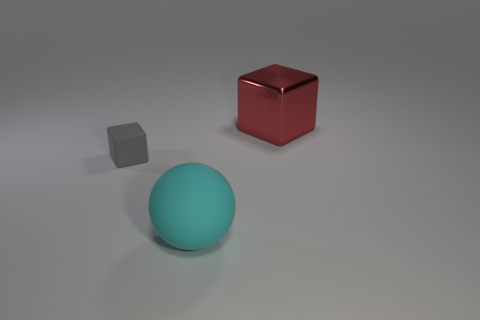Do the big block and the object that is in front of the small gray rubber block have the same color?
Your answer should be very brief. No. Is the number of small purple cylinders greater than the number of big red metallic objects?
Keep it short and to the point. No. What size is the red object that is the same shape as the gray object?
Offer a very short reply. Large. Are the large ball and the big thing that is behind the large cyan rubber object made of the same material?
Offer a very short reply. No. How many objects are red blocks or large cyan rubber objects?
Your answer should be very brief. 2. There is a rubber object to the right of the gray rubber block; is it the same size as the block that is to the left of the big cyan thing?
Make the answer very short. No. How many balls are either gray things or cyan matte things?
Your answer should be very brief. 1. Are any large red blocks visible?
Make the answer very short. Yes. Are there any other things that have the same shape as the large matte thing?
Provide a succinct answer. No. Does the tiny thing have the same color as the metallic object?
Give a very brief answer. No. 